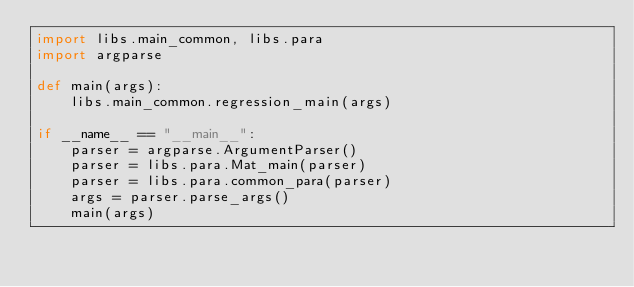Convert code to text. <code><loc_0><loc_0><loc_500><loc_500><_Python_>import libs.main_common, libs.para
import argparse

def main(args):
    libs.main_common.regression_main(args)

if __name__ == "__main__":
    parser = argparse.ArgumentParser()
    parser = libs.para.Mat_main(parser)
    parser = libs.para.common_para(parser)
    args = parser.parse_args()
    main(args)</code> 